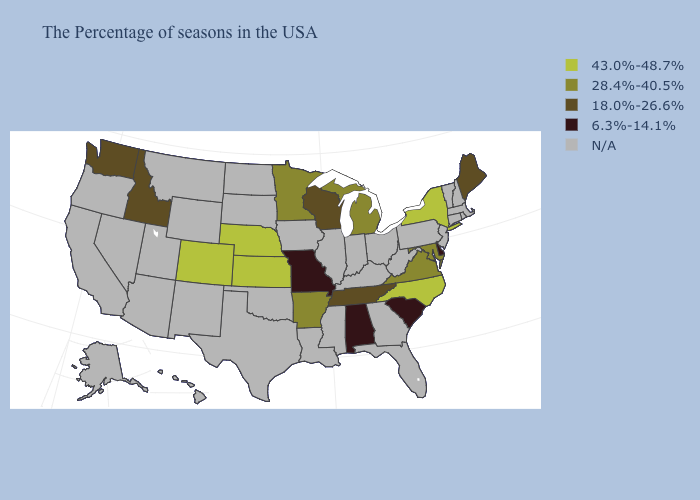Among the states that border Wisconsin , which have the highest value?
Write a very short answer. Michigan, Minnesota. What is the value of Iowa?
Write a very short answer. N/A. What is the lowest value in the MidWest?
Give a very brief answer. 6.3%-14.1%. What is the value of Alaska?
Keep it brief. N/A. Among the states that border Arkansas , which have the highest value?
Quick response, please. Tennessee. Name the states that have a value in the range 28.4%-40.5%?
Answer briefly. Maryland, Virginia, Michigan, Arkansas, Minnesota. What is the value of Louisiana?
Concise answer only. N/A. Name the states that have a value in the range 6.3%-14.1%?
Quick response, please. Delaware, South Carolina, Alabama, Missouri. What is the value of Nevada?
Answer briefly. N/A. Among the states that border New Jersey , which have the lowest value?
Short answer required. Delaware. What is the value of Kansas?
Give a very brief answer. 43.0%-48.7%. Among the states that border Arkansas , which have the highest value?
Quick response, please. Tennessee. Does Maine have the lowest value in the Northeast?
Quick response, please. Yes. Does Missouri have the lowest value in the MidWest?
Give a very brief answer. Yes. 